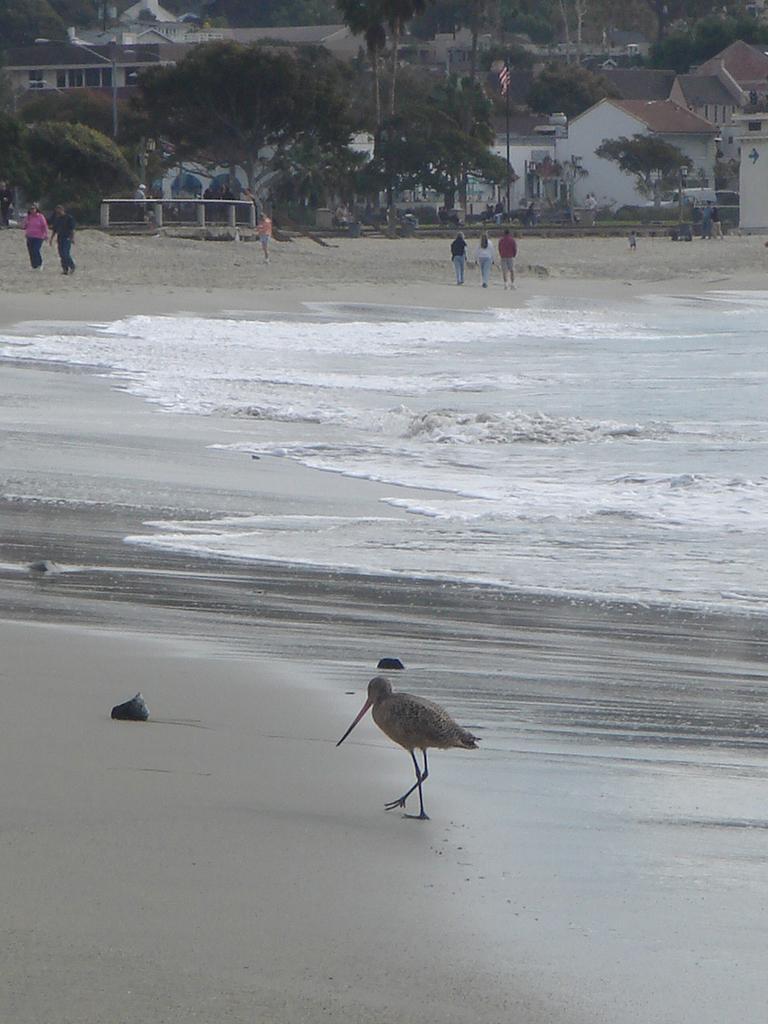Could you give a brief overview of what you see in this image? In this image we can see people standing and we can also see a bird, water trees and houses. 